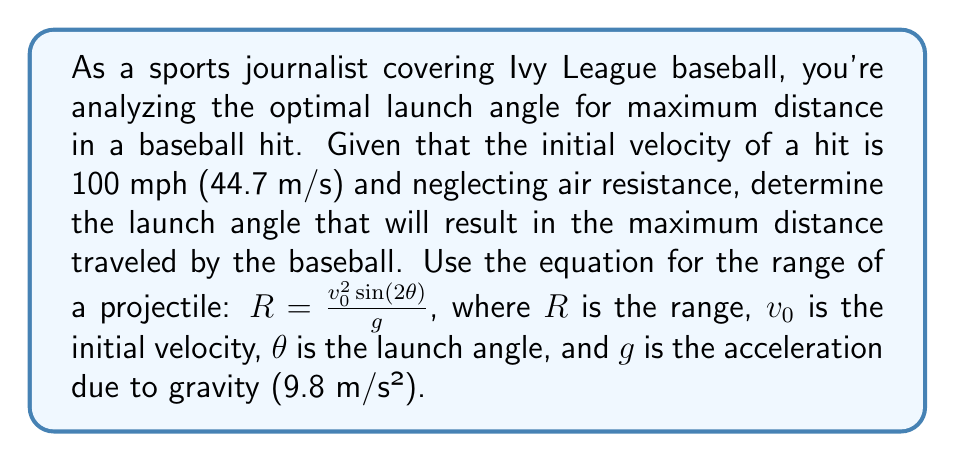Show me your answer to this math problem. To find the optimal launch angle for maximum distance, we need to maximize the range equation with respect to $\theta$. Let's approach this step-by-step:

1) The range equation is given by:
   $$R = \frac{v_0^2 \sin(2\theta)}{g}$$

2) To maximize R, we need to maximize $\sin(2\theta)$. The maximum value of sine is 1, which occurs when its argument is 90°.

3) Therefore, the maximum range occurs when:
   $$2\theta = 90°$$
   $$\theta = 45°$$

4) We can verify this by taking the derivative of R with respect to $\theta$ and setting it to zero:
   $$\frac{dR}{d\theta} = \frac{v_0^2}{g} \cdot 2\cos(2\theta) = 0$$

5) This equation is satisfied when $\cos(2\theta) = 0$, which occurs when $2\theta = 90°$, confirming our earlier conclusion.

6) Therefore, the optimal launch angle for maximum distance is 45°.

Note: This result is true in the absence of air resistance. In real-world scenarios with air resistance, the optimal angle is typically slightly lower, around 35-40 degrees depending on various factors.
Answer: 45° 